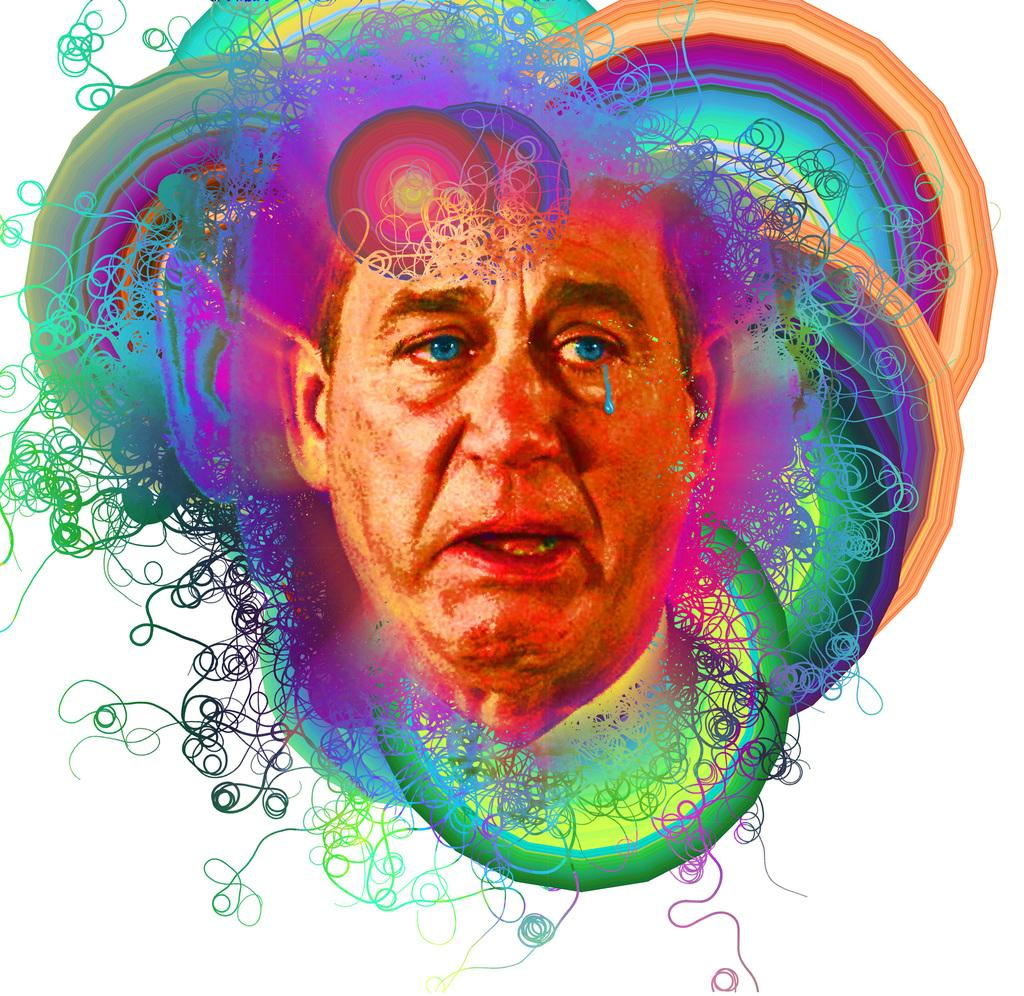What type of editing has been done to the image? The image is edited, but the specific type of editing is not mentioned in the facts. What can be seen in the image? There is a person's face in the image. Can you describe the colors in the image? There are different colors in the image. Is there a cap visible on the person's head in the image? There is no mention of a cap in the image, so it cannot be determined if one is present. 